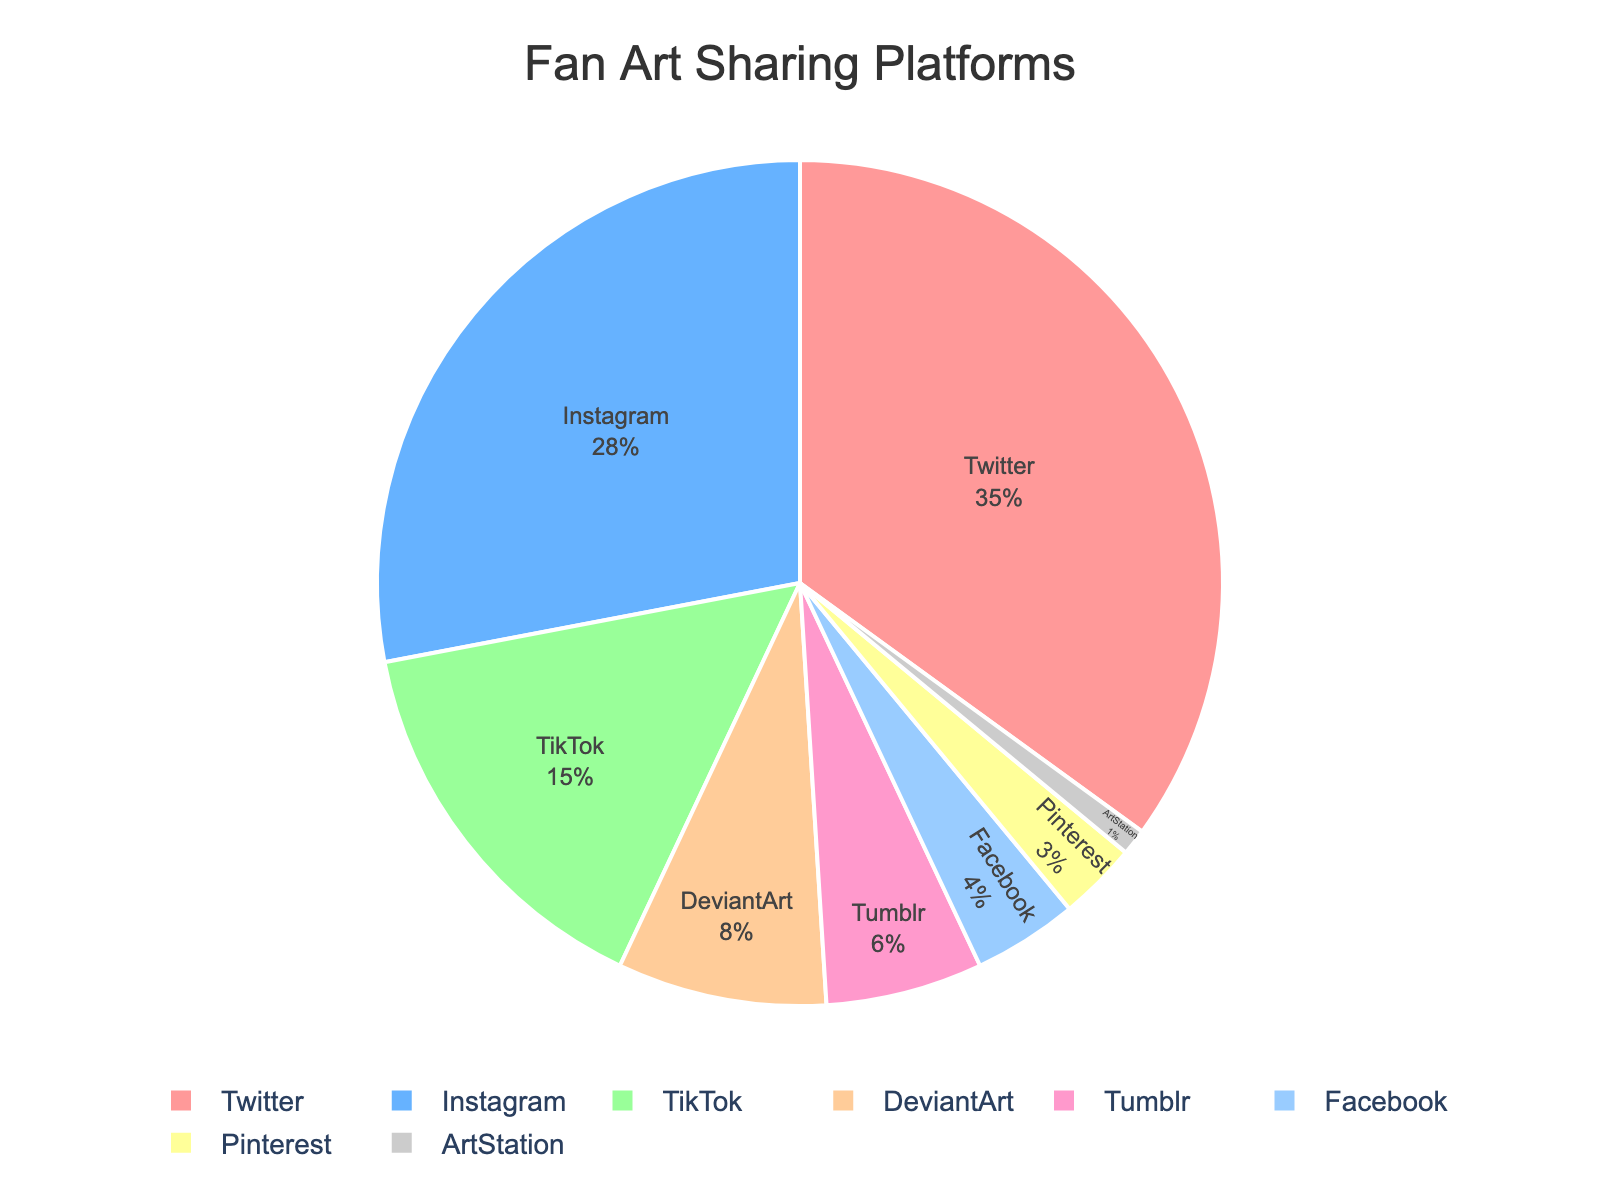What's the largest social media platform for fan art sharing shown in the pie chart? The pie chart indicates percentages of various platforms used for fan art sharing. The platform with the highest percentage is Twitter with 35%.
Answer: Twitter Which platform has the smallest percentage in the pie chart? The pie chart displays percentages for different platforms. The platform with the lowest percentage, at 1%, is ArtStation.
Answer: ArtStation What is the combined percentage of fan art shared on TikTok and Instagram? To find the combined percentage for TikTok and Instagram, add their individual percentages: TikTok (15%) and Instagram (28%). Thus, 15 + 28 = 43%.
Answer: 43% How does the percentage of fan art on Facebook compare to that on Pinterest? The pie chart shows Facebook with 4% and Pinterest with 3%. Therefore, Facebook's percentage is 1% higher than Pinterest's.
Answer: Facebook's percentage is higher by 1% What is the difference in percentage between fan art shared on Twitter and Tumblr? Twitter has 35% and Tumblr has 6%, so the difference is 35 - 6 = 29%.
Answer: 29% Which two platforms combined nearly equal the total percentage of Twitter? We need two platforms that sum to approximately 35%. Instagram (28%) and TikTok (15%) combined give 28 + 15 = 43%, which is closer. Another combination does not come closer than this.
Answer: Instagram and TikTok Are any platforms within 2% of each other? The chart shows that Facebook is at 4% and Pinterest is at 3%. Their difference is 4 - 3 = 1%, which is within 2%.
Answer: Yes, Facebook and Pinterest What is the total percentage for platforms with less than 10% usage each? Sum percentages for DeviantArt (8%), Tumblr (6%), Facebook (4%), Pinterest (3%), and ArtStation (1%): 8 + 6 + 4 + 3 + 1 = 22%.
Answer: 22% What is the percentage difference between the two highest platforms? The two highest platforms are Twitter (35%) and Instagram (28%). Their difference is 35 - 28 = 7%.
Answer: 7% What percentage of fan art is shared on platforms other than Twitter? Subtract Twitter's percentage (35%) from the total (100%): 100 - 35 = 65%.
Answer: 65% 